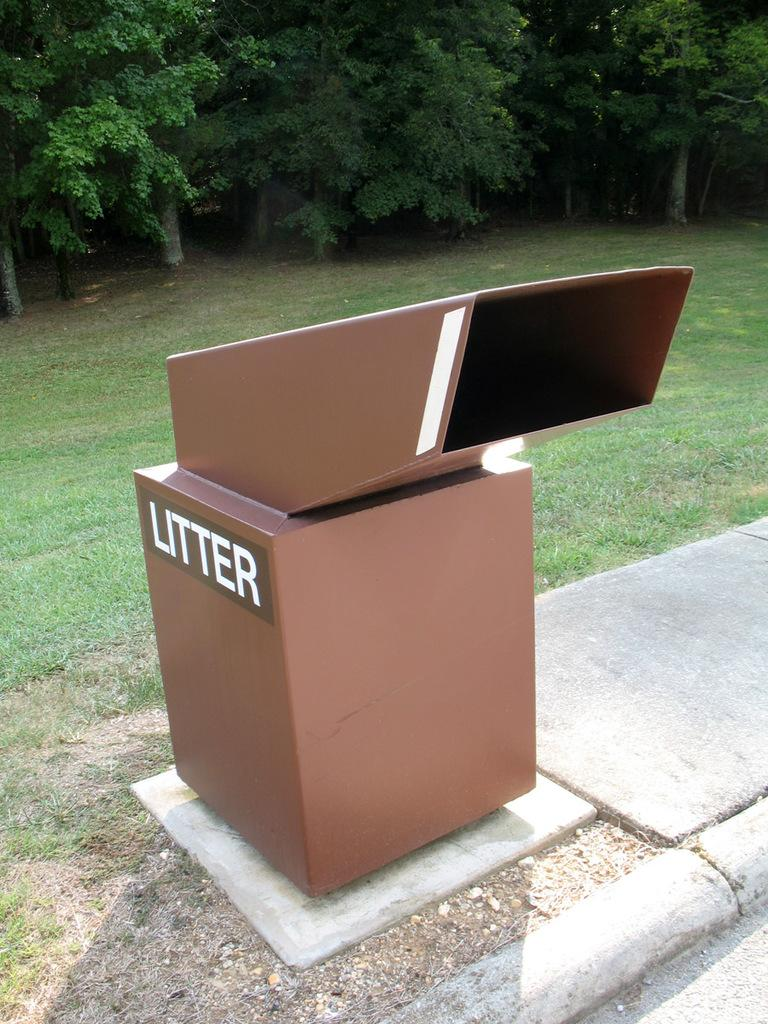What is the color of the box in the image? The box in the image is brown. What is written on the box? The word "litter" is written on the box. What type of natural environment is visible in the image? There is grass visible in the image. What can be seen in the background of the image? There are trees in the background of the image. What type of calculator is being used to measure the distance between the trees in the image? There is no calculator present in the image, and no measurements are being taken. 